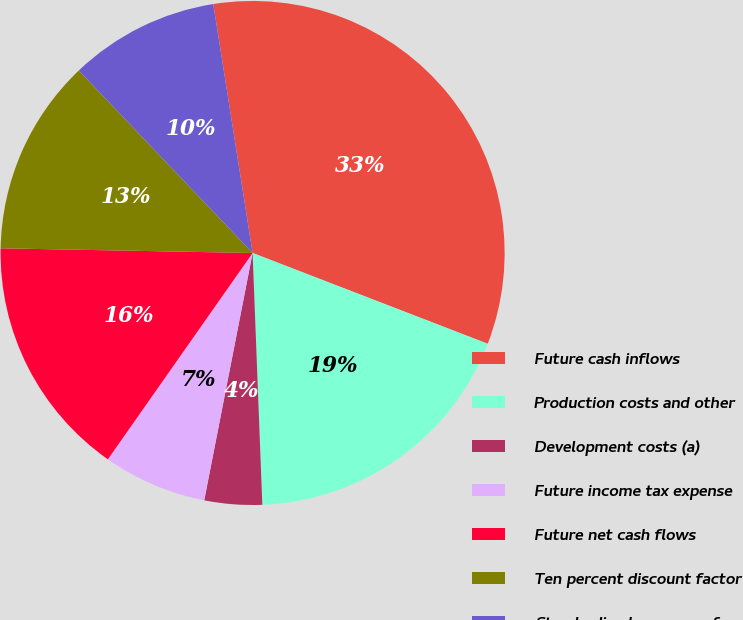Convert chart. <chart><loc_0><loc_0><loc_500><loc_500><pie_chart><fcel>Future cash inflows<fcel>Production costs and other<fcel>Development costs (a)<fcel>Future income tax expense<fcel>Future net cash flows<fcel>Ten percent discount factor<fcel>Standardized measure of<nl><fcel>33.36%<fcel>18.52%<fcel>3.69%<fcel>6.66%<fcel>15.56%<fcel>12.59%<fcel>9.62%<nl></chart> 